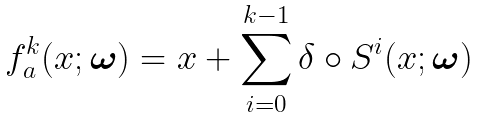<formula> <loc_0><loc_0><loc_500><loc_500>f _ { a } ^ { k } ( x ; { \boldsymbol \omega } ) = x + \sum _ { i = 0 } ^ { k - 1 } \delta \circ S ^ { i } ( x ; { \boldsymbol \omega } )</formula> 